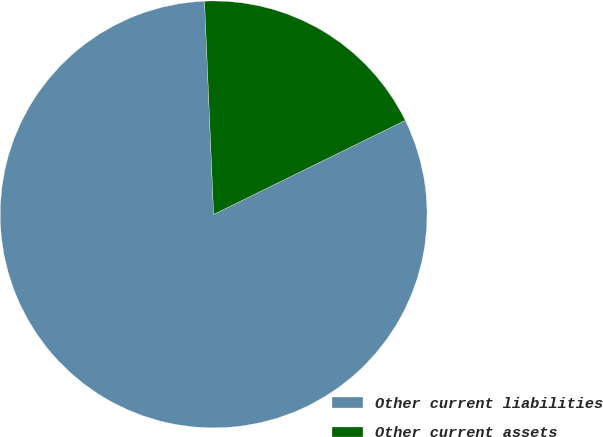Convert chart to OTSL. <chart><loc_0><loc_0><loc_500><loc_500><pie_chart><fcel>Other current liabilities<fcel>Other current assets<nl><fcel>81.58%<fcel>18.42%<nl></chart> 